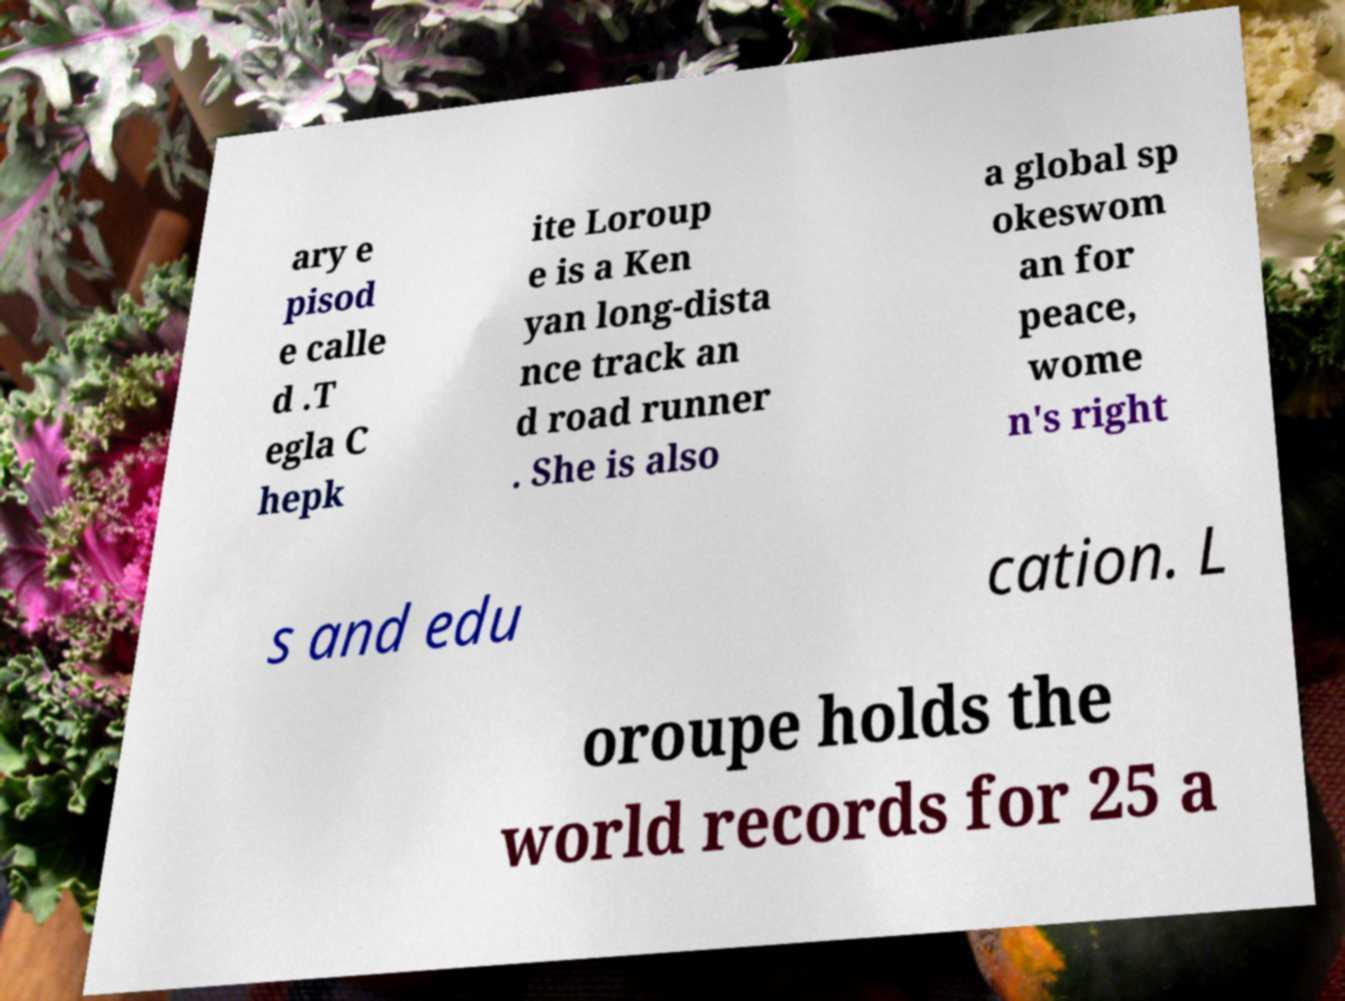Could you assist in decoding the text presented in this image and type it out clearly? ary e pisod e calle d .T egla C hepk ite Loroup e is a Ken yan long-dista nce track an d road runner . She is also a global sp okeswom an for peace, wome n's right s and edu cation. L oroupe holds the world records for 25 a 